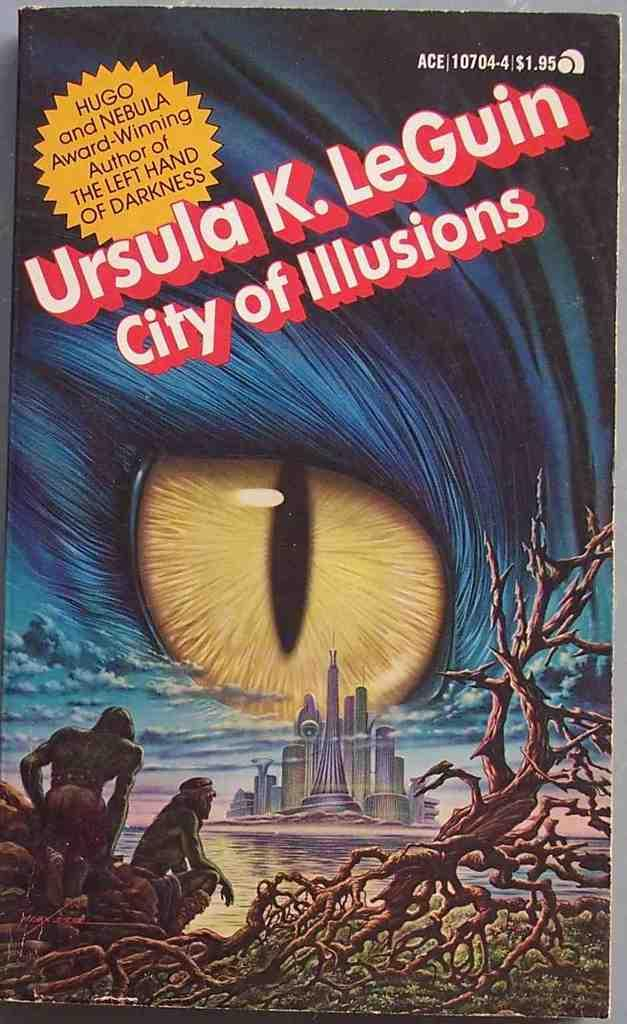Provide a one-sentence caption for the provided image. Ursula K. LeGuin's book has a big eye on the cover and sells for $1.95. 